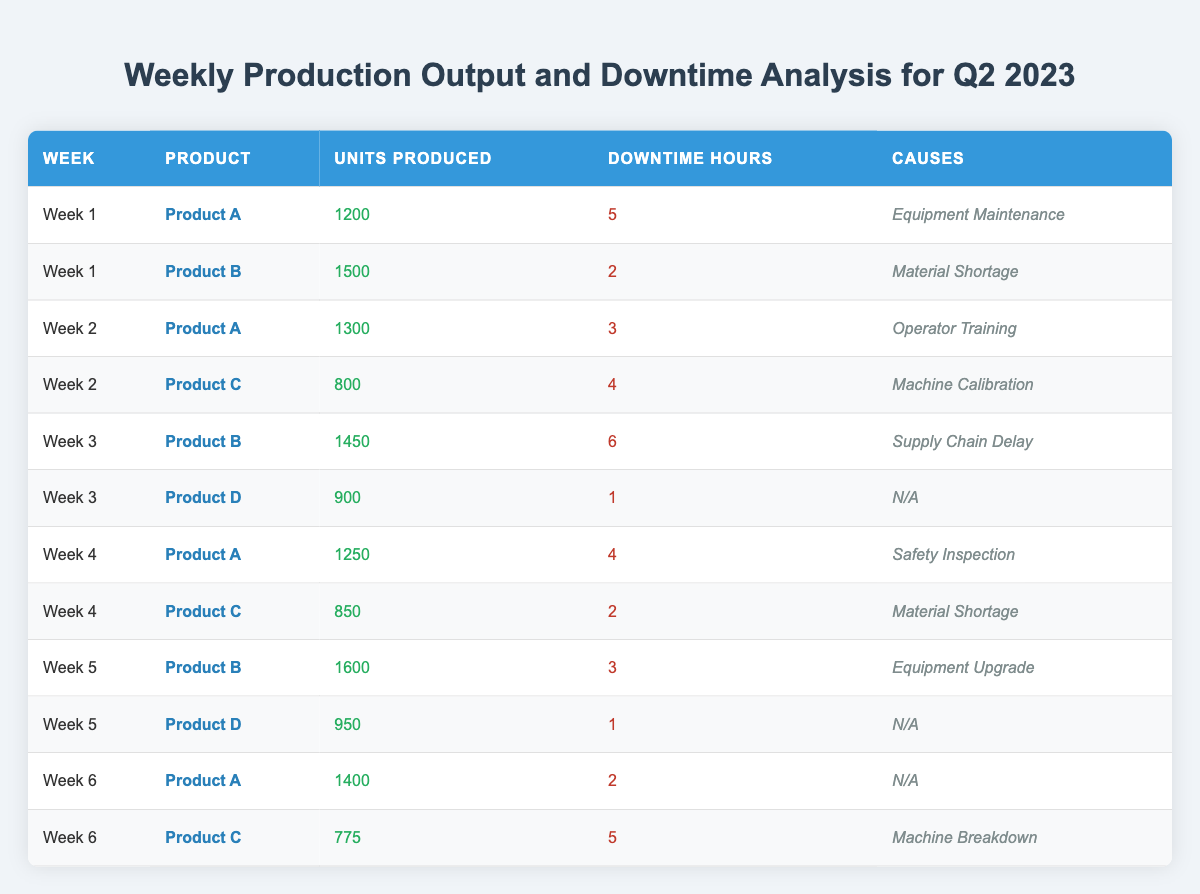What was the total production output for Product A in Week 1 and Week 2? Product A produced 1200 units in Week 1 and 1300 units in Week 2. Adding these gives 1200 + 1300 = 2500.
Answer: 2500 Which product had the highest production output in Week 5? In Week 5, Product B had the highest production output with 1600 units produced, compared to Product D with 950 units.
Answer: Product B What is the total downtime recorded for Product C across all weeks? Product C recorded downtime of 4 hours in Week 2, 2 hours in Week 4, and 5 hours in Week 6. Adding these gives 4 + 2 + 5 = 11 hours.
Answer: 11 hours Did Product D experience any downtime in Week 3? In Week 3, Product D recorded 1 hour of downtime, which means it did experience downtime.
Answer: Yes What is the average units produced for Product B over the six weeks? Product B produced 1500 (Week 1) + 1450 (Week 3) + 1600 (Week 5) = 4550 total units over 3 weeks. Dividing 4550 by 3 gives an average of 1516.67.
Answer: 1516.67 Which cause of downtime was the most frequent for Product A? Product A had downtime caused by Equipment Maintenance (Week 1), Operator Training (Week 2), and Safety Inspection (Week 4). Each cause occurred once, so they are equally frequent.
Answer: None was more frequent What product had the least units produced in Week 6, and how many were produced? In Week 6, Product C had the least units produced, with 775 compared to Product A's 1400.
Answer: Product C, 775 units How many total downtime hours were recorded throughout Week 3? The total downtime in Week 3 is the sum of downtime hours for Product B (6 hours) and Product D (1 hour), totaling 6 + 1 = 7 hours.
Answer: 7 hours Which week had the highest total units produced, and what was that total? The total units produced in Week 5 are 1600 (Product B) + 950 (Product D) = 2550. In comparison, other weeks fall short. Thus, Week 5 had the highest total.
Answer: Week 5, 2550 units What is the difference in downtime hours between Week 1 and Week 5? Week 1 had a total downtime of 5 (Product A) + 2 (Product B) = 7 hours. Week 5 had a total of 3 (Product B) + 1 (Product D) = 4 hours. The difference is 7 - 4 = 3 hours.
Answer: 3 hours 